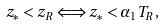<formula> <loc_0><loc_0><loc_500><loc_500>z _ { * } < z _ { R } \Longleftrightarrow z _ { * } < \alpha _ { 1 } T _ { R } ,</formula> 